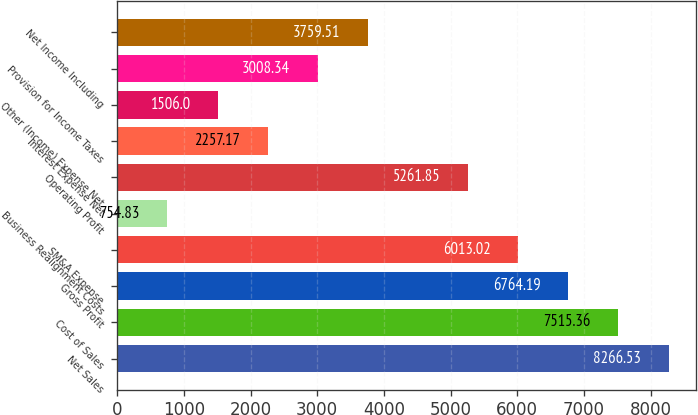Convert chart to OTSL. <chart><loc_0><loc_0><loc_500><loc_500><bar_chart><fcel>Net Sales<fcel>Cost of Sales<fcel>Gross Profit<fcel>SM&A Expense<fcel>Business Realignment Costs<fcel>Operating Profit<fcel>Interest Expense Net<fcel>Other (Income) Expense Net<fcel>Provision for Income Taxes<fcel>Net Income Including<nl><fcel>8266.53<fcel>7515.36<fcel>6764.19<fcel>6013.02<fcel>754.83<fcel>5261.85<fcel>2257.17<fcel>1506<fcel>3008.34<fcel>3759.51<nl></chart> 